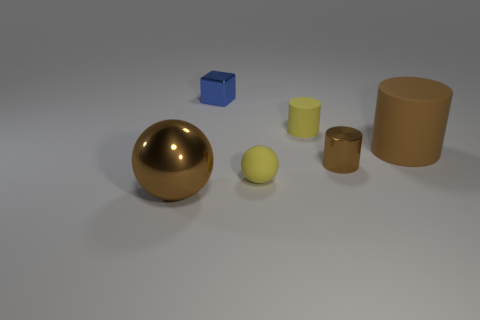There is a matte thing that is the same color as the small rubber sphere; what shape is it?
Your response must be concise. Cylinder. How many things are either metallic objects that are on the right side of the blue object or big blue metallic cylinders?
Your response must be concise. 1. How many other objects are the same size as the metal cylinder?
Ensure brevity in your answer.  3. What material is the small cylinder behind the large thing that is on the right side of the big brown thing in front of the rubber ball?
Offer a very short reply. Rubber. What number of cylinders are tiny things or small yellow rubber objects?
Your answer should be very brief. 2. Is there anything else that has the same shape as the small blue thing?
Give a very brief answer. No. Is the number of large objects on the right side of the small brown cylinder greater than the number of large brown shiny spheres that are left of the big metal ball?
Your response must be concise. Yes. There is a cube on the right side of the metal sphere; what number of brown metal things are on the right side of it?
Keep it short and to the point. 1. What number of things are tiny yellow cylinders or brown metal things?
Your answer should be very brief. 3. Is the tiny brown thing the same shape as the large brown rubber thing?
Your answer should be compact. Yes. 